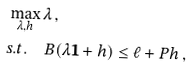Convert formula to latex. <formula><loc_0><loc_0><loc_500><loc_500>& \max _ { \lambda , h } \lambda \, , \\ & s . t . \quad B ( \lambda \mathbf 1 + h ) \leq \ell + P h \, ,</formula> 